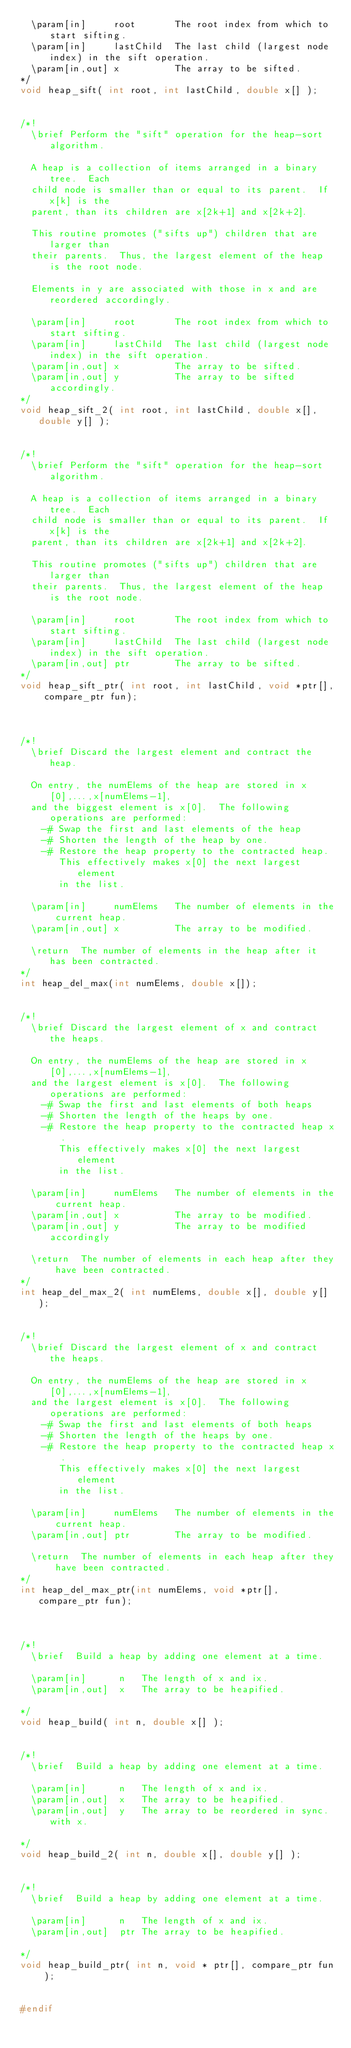<code> <loc_0><loc_0><loc_500><loc_500><_C_>  \param[in]     root       The root index from which to start sifting.
  \param[in]     lastChild  The last child (largest node index) in the sift operation.
  \param[in,out] x          The array to be sifted.
*/
void heap_sift( int root, int lastChild, double x[] );


/*!
  \brief Perform the "sift" operation for the heap-sort algorithm.

  A heap is a collection of items arranged in a binary tree.  Each
  child node is smaller than or equal to its parent.  If x[k] is the
  parent, than its children are x[2k+1] and x[2k+2].

  This routine promotes ("sifts up") children that are larger than
  their parents.  Thus, the largest element of the heap is the root node.

  Elements in y are associated with those in x and are reordered accordingly.

  \param[in]     root       The root index from which to start sifting.
  \param[in]     lastChild  The last child (largest node index) in the sift operation.
  \param[in,out] x          The array to be sifted.
  \param[in,out] y          The array to be sifted accordingly.
*/
void heap_sift_2( int root, int lastChild, double x[], double y[] );


/*!
  \brief Perform the "sift" operation for the heap-sort algorithm.

  A heap is a collection of items arranged in a binary tree.  Each
  child node is smaller than or equal to its parent.  If x[k] is the
  parent, than its children are x[2k+1] and x[2k+2].

  This routine promotes ("sifts up") children that are larger than
  their parents.  Thus, the largest element of the heap is the root node.

  \param[in]     root       The root index from which to start sifting.
  \param[in]     lastChild  The last child (largest node index) in the sift operation.
  \param[in,out] ptr        The array to be sifted.
*/
void heap_sift_ptr( int root, int lastChild, void *ptr[], compare_ptr fun);



/*!
  \brief Discard the largest element and contract the heap.

  On entry, the numElems of the heap are stored in x[0],...,x[numElems-1],
  and the biggest element is x[0].  The following operations are performed:
    -# Swap the first and last elements of the heap
    -# Shorten the length of the heap by one.
    -# Restore the heap property to the contracted heap.
       This effectively makes x[0] the next largest element
       in the list.

  \param[in]     numElems   The number of elements in the current heap.
  \param[in,out] x          The array to be modified.

  \return  The number of elements in the heap after it has been contracted.
*/
int heap_del_max(int numElems, double x[]);


/*!
  \brief Discard the largest element of x and contract the heaps.

  On entry, the numElems of the heap are stored in x[0],...,x[numElems-1],
  and the largest element is x[0].  The following operations are performed:
    -# Swap the first and last elements of both heaps
    -# Shorten the length of the heaps by one.
    -# Restore the heap property to the contracted heap x.
       This effectively makes x[0] the next largest element
       in the list.  

  \param[in]     numElems   The number of elements in the current heap.
  \param[in,out] x          The array to be modified.
  \param[in,out] y          The array to be modified accordingly

  \return  The number of elements in each heap after they have been contracted.
*/
int heap_del_max_2( int numElems, double x[], double y[] );


/*!
  \brief Discard the largest element of x and contract the heaps.

  On entry, the numElems of the heap are stored in x[0],...,x[numElems-1],
  and the largest element is x[0].  The following operations are performed:
    -# Swap the first and last elements of both heaps
    -# Shorten the length of the heaps by one.
    -# Restore the heap property to the contracted heap x.
       This effectively makes x[0] the next largest element
       in the list.  

  \param[in]     numElems   The number of elements in the current heap.
  \param[in,out] ptr        The array to be modified.

  \return  The number of elements in each heap after they have been contracted.
*/
int heap_del_max_ptr(int numElems, void *ptr[], compare_ptr fun);



/*!
  \brief  Build a heap by adding one element at a time.
  
  \param[in]      n   The length of x and ix.
  \param[in,out]  x   The array to be heapified.

*/
void heap_build( int n, double x[] );


/*!
  \brief  Build a heap by adding one element at a time.
  
  \param[in]      n   The length of x and ix.
  \param[in,out]  x   The array to be heapified.
  \param[in,out]  y   The array to be reordered in sync. with x.

*/
void heap_build_2( int n, double x[], double y[] );


/*!
  \brief  Build a heap by adding one element at a time.
  
  \param[in]      n   The length of x and ix.
  \param[in,out]  ptr The array to be heapified.

*/
void heap_build_ptr( int n, void * ptr[], compare_ptr fun );


#endif
</code> 